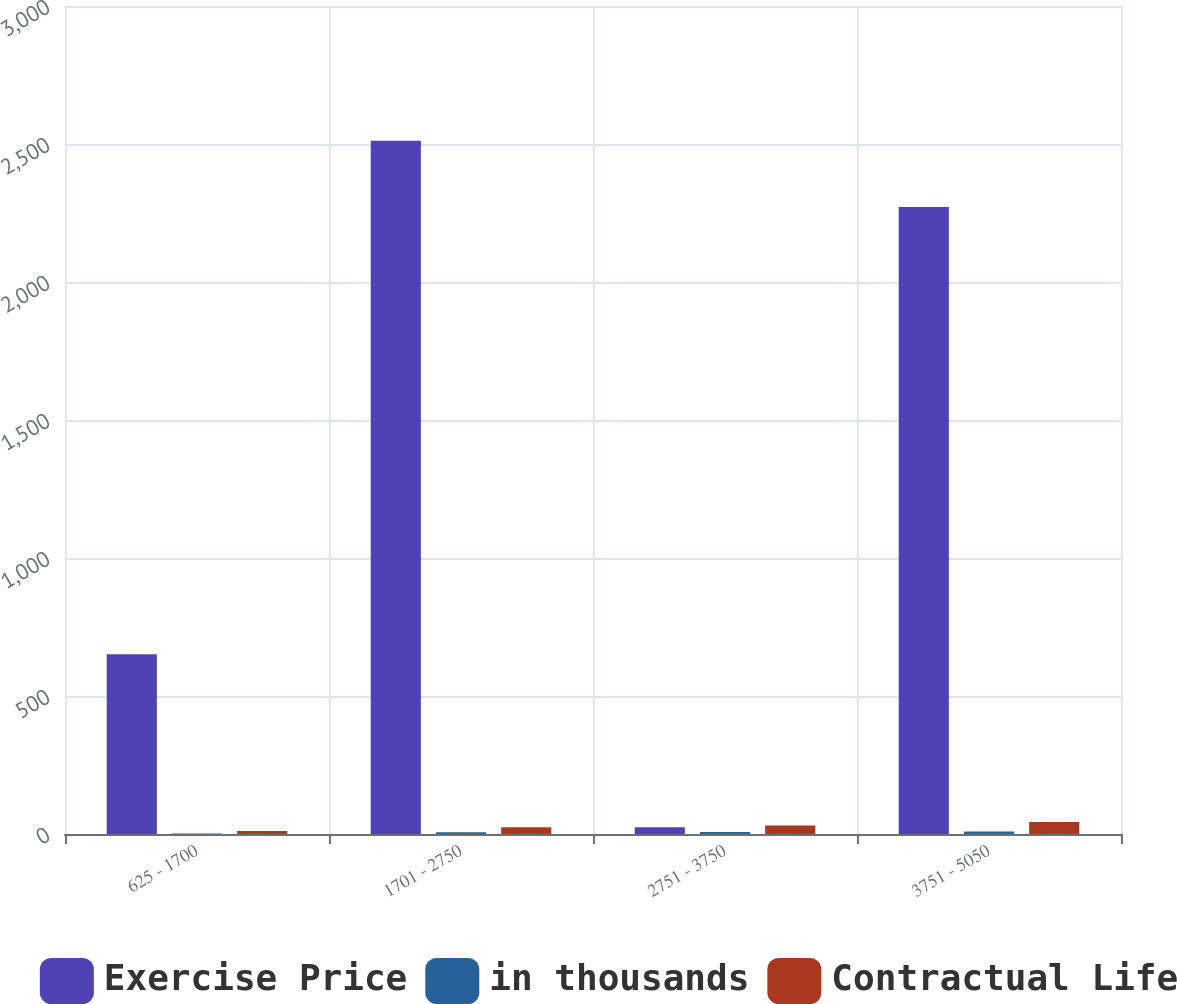Convert chart. <chart><loc_0><loc_0><loc_500><loc_500><stacked_bar_chart><ecel><fcel>625 - 1700<fcel>1701 - 2750<fcel>2751 - 3750<fcel>3751 - 5050<nl><fcel>Exercise Price<fcel>651<fcel>2512<fcel>24.82<fcel>2272<nl><fcel>in thousands<fcel>1.93<fcel>5.93<fcel>7.13<fcel>9.23<nl><fcel>Contractual Life<fcel>10.76<fcel>24.82<fcel>30.74<fcel>43.17<nl></chart> 